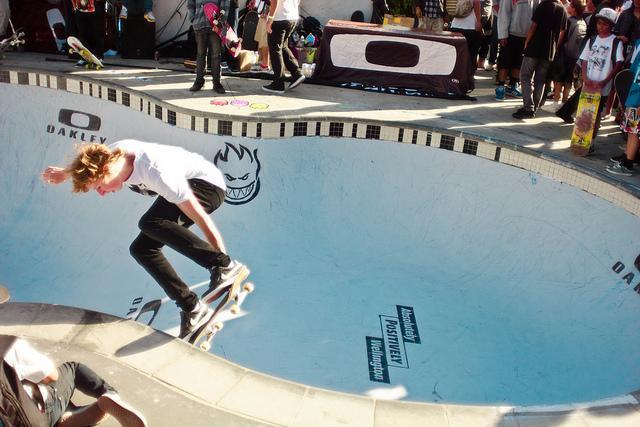What's happening to this guy?
Pick the right solution, then justify: 'Answer: answer
Rationale: rationale.'
Options: Bouncing, being chased, falling, doing tricks. Answer: doing tricks.
Rationale: The guy is grabbing his skateboard as he's coming out of an empty pool. 